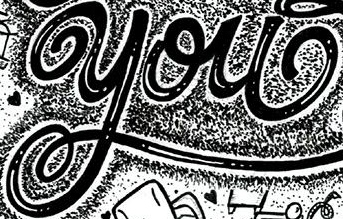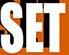Read the text content from these images in order, separated by a semicolon. you; SET 